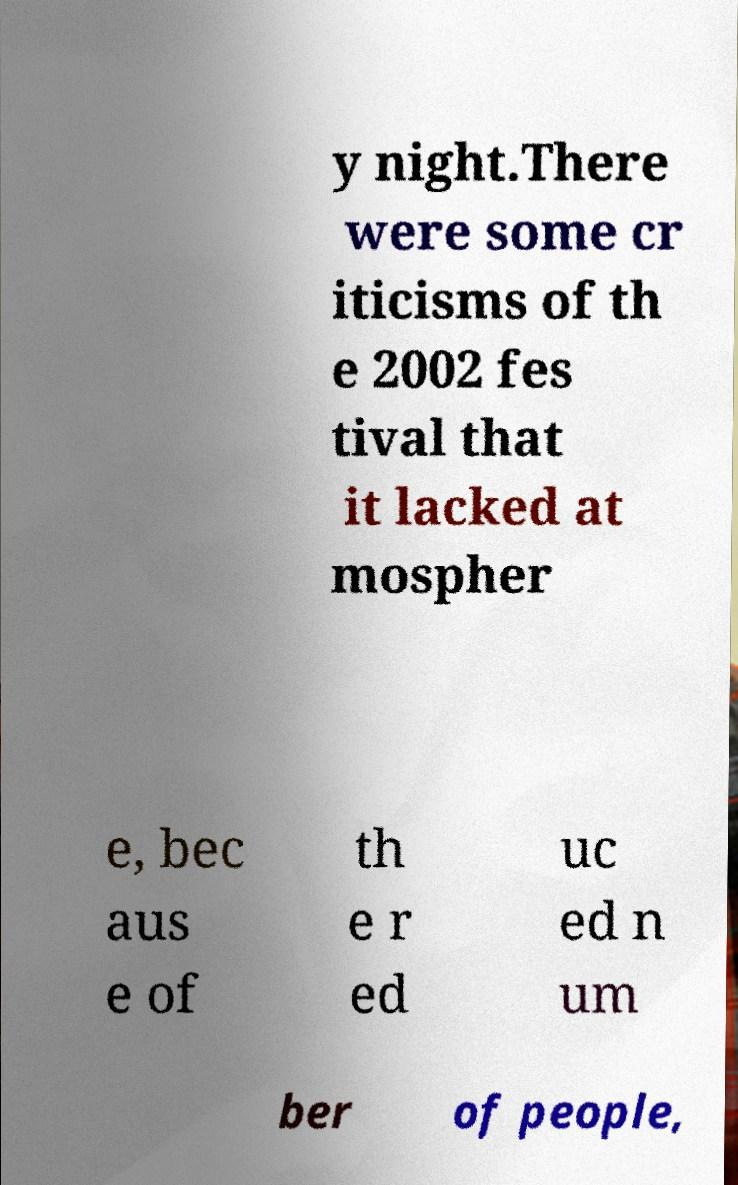I need the written content from this picture converted into text. Can you do that? y night.There were some cr iticisms of th e 2002 fes tival that it lacked at mospher e, bec aus e of th e r ed uc ed n um ber of people, 